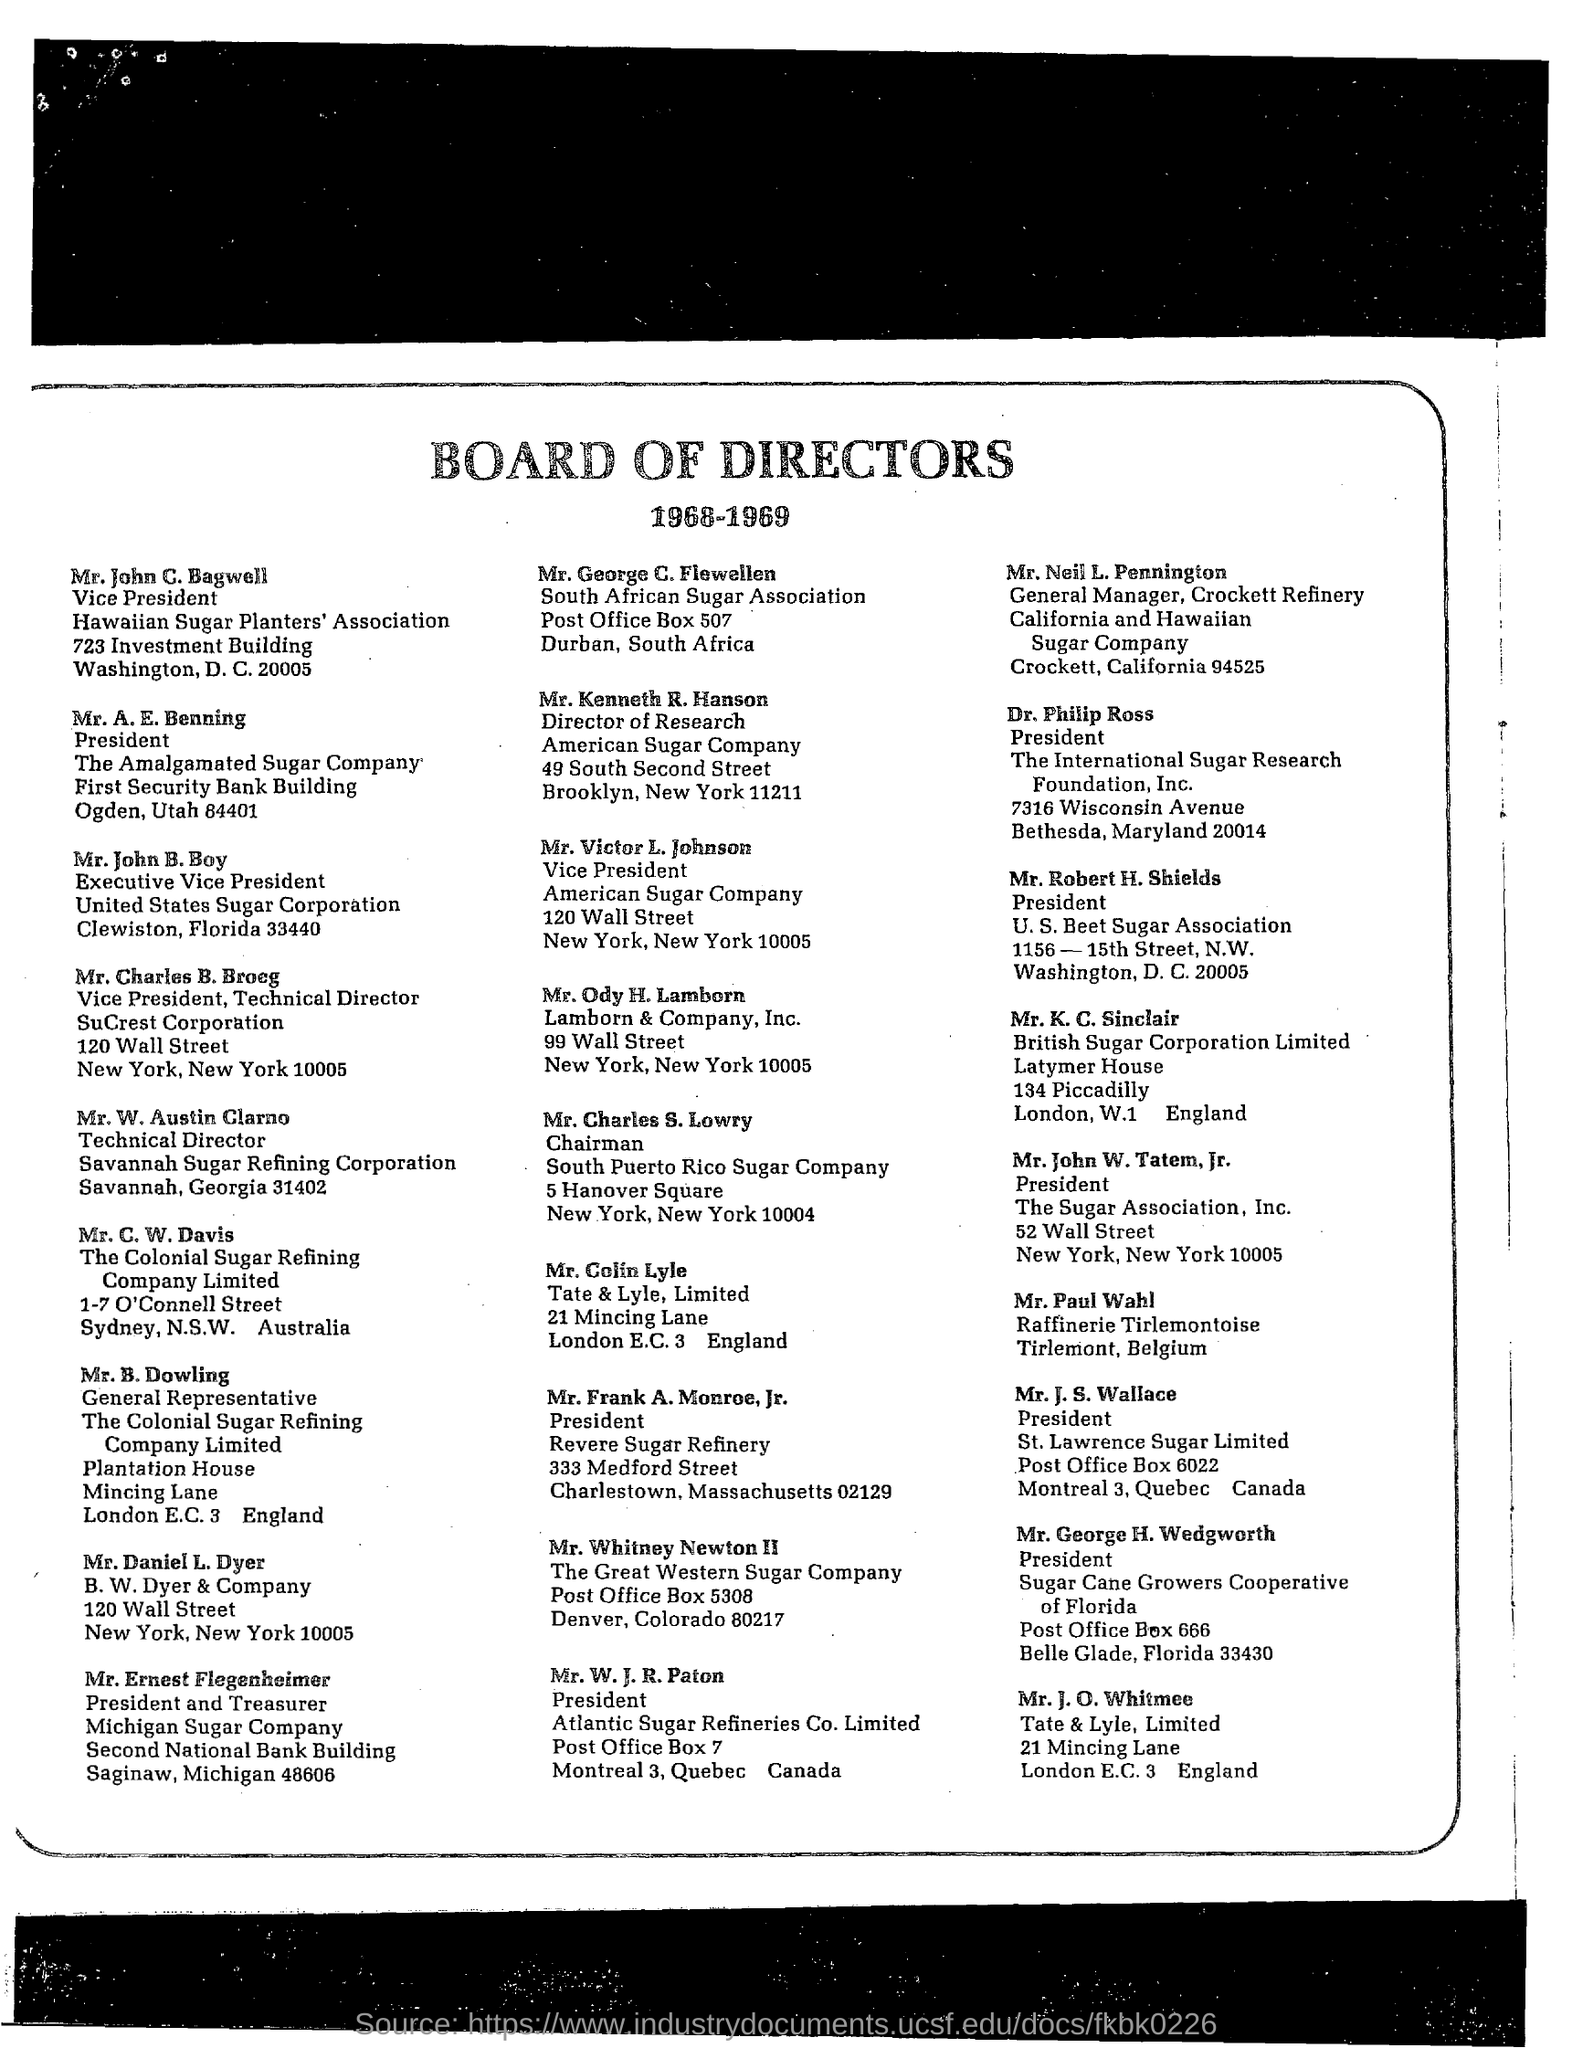Who was the Director of The Great Western Sugar Company?
Provide a short and direct response. Mr. whitney newton ii. 